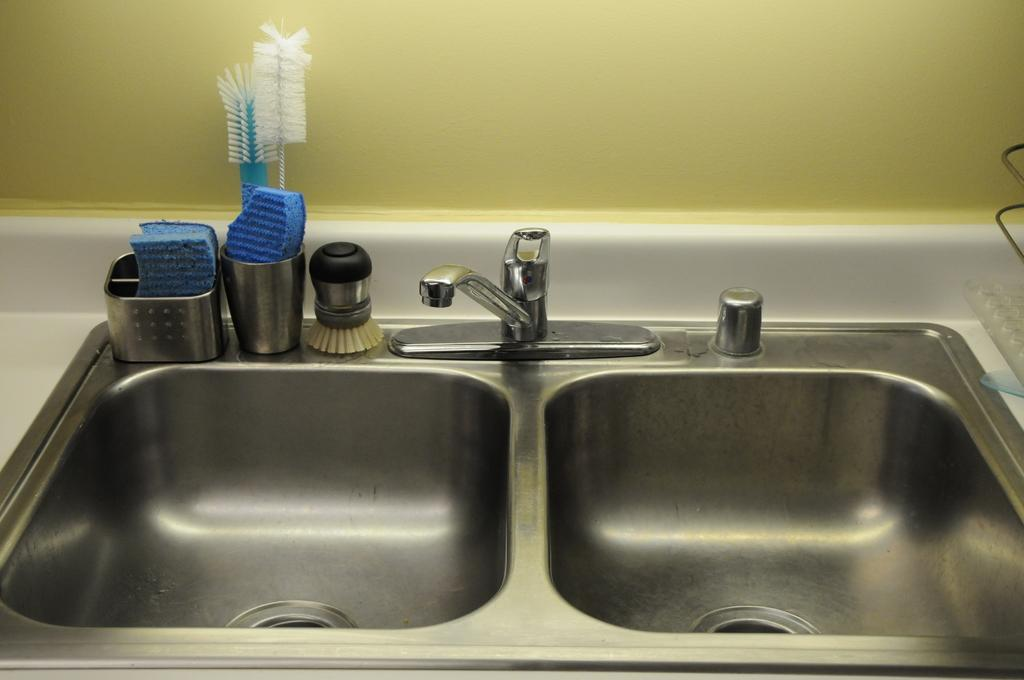What type of fixtures are present in the image? There are sinks in the image. What is used to control the flow of water in the image? There is a water tap in the image. image. What tools are visible in the image? There are brushes in the image. What type of container is present in the image? There is a glass in the image. Can you describe any other items that are not specified in the image? There are other unspecified items in the image. What type of act is being performed by the oranges in the image? There are no oranges present in the image, so no act can be performed by them. What type of blade is visible in the image? There is no blade visible in the image. 